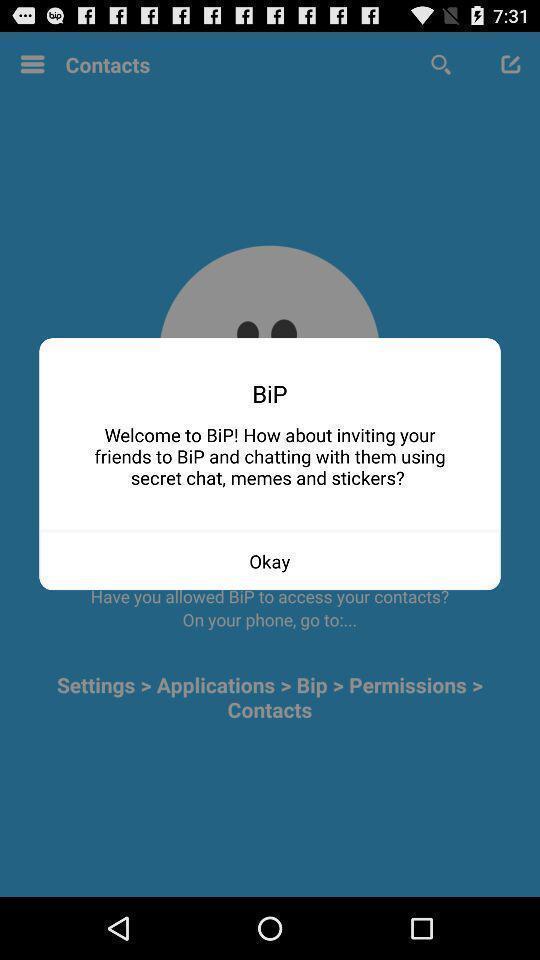Explain the elements present in this screenshot. Pop-up showing to invite a friend in a chat app. 